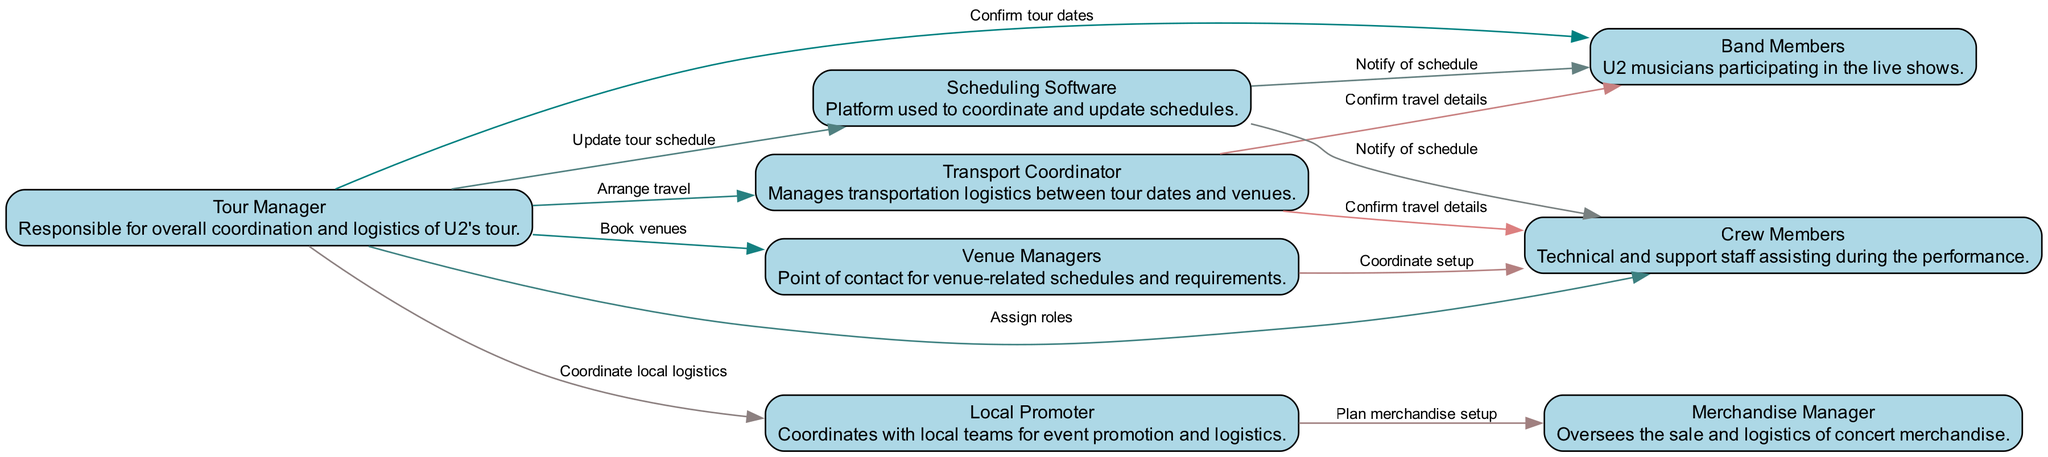What is the role of the Tour Manager? The Tour Manager is responsible for overall coordination and logistics of U2's tour, as indicated in the diagram. This includes confirming tour dates, booking venues, and assigning roles to crew members.
Answer: overall coordination and logistics How many nodes are in the diagram? The diagram contains eight distinct elements represented as nodes: Tour Manager, Band Members, Crew Members, Venue Managers, Transport Coordinator, Scheduling Software, Merchandise Manager, and Local Promoter. By counting each of these, we find there are eight nodes.
Answer: eight Which elements communicate with the Scheduling Software? The diagram shows that both Band Members and Crew Members are notified of the schedule by the Scheduling Software. Additionally, the Tour Manager updates the tour schedule in the Scheduling Software. This means the elements communicating with it are Tour Manager, Band Members, and Crew Members.
Answer: Tour Manager, Band Members, Crew Members What is the first action taken by the Tour Manager? The first action taken by the Tour Manager is to confirm tour dates with the Band Members. This is indicated as the first connection made by the Tour Manager in the sequence of interactions.
Answer: Confirm tour dates How many edges connect the Crew Members to other elements? The Crew Members have three edges connecting them to other elements: one coming from the Tour Manager (assign roles), another from Venue Managers (coordinate setup), and a third from the Transport Coordinator (confirm travel details). By counting these connections, we find there are three edges.
Answer: three Which element is responsible for transportation logistics? The Transport Coordinator manages the transportation logistics between tour dates and venues, which is the primary responsibility mentioned in the diagram. This can be identified directly with the description attached to the Transport Coordinator node.
Answer: Transport Coordinator Which element does the Local Promoter coordinate with for event promotion and logistics? The Local Promoter coordinates with the Merchandise Manager to plan for merchandise setup, as represented in the connections of the diagram. This illustrates the collaborative role of the Local Promoter in local event logistics and promotion.
Answer: Merchandise Manager What type of software is used in the coordination process? The diagram specifies that Scheduling Software is the platform used to coordinate and update schedules among the various elements involved in the tour logistics. This highlights the importance of a centralized scheduling system in the process.
Answer: Scheduling Software 